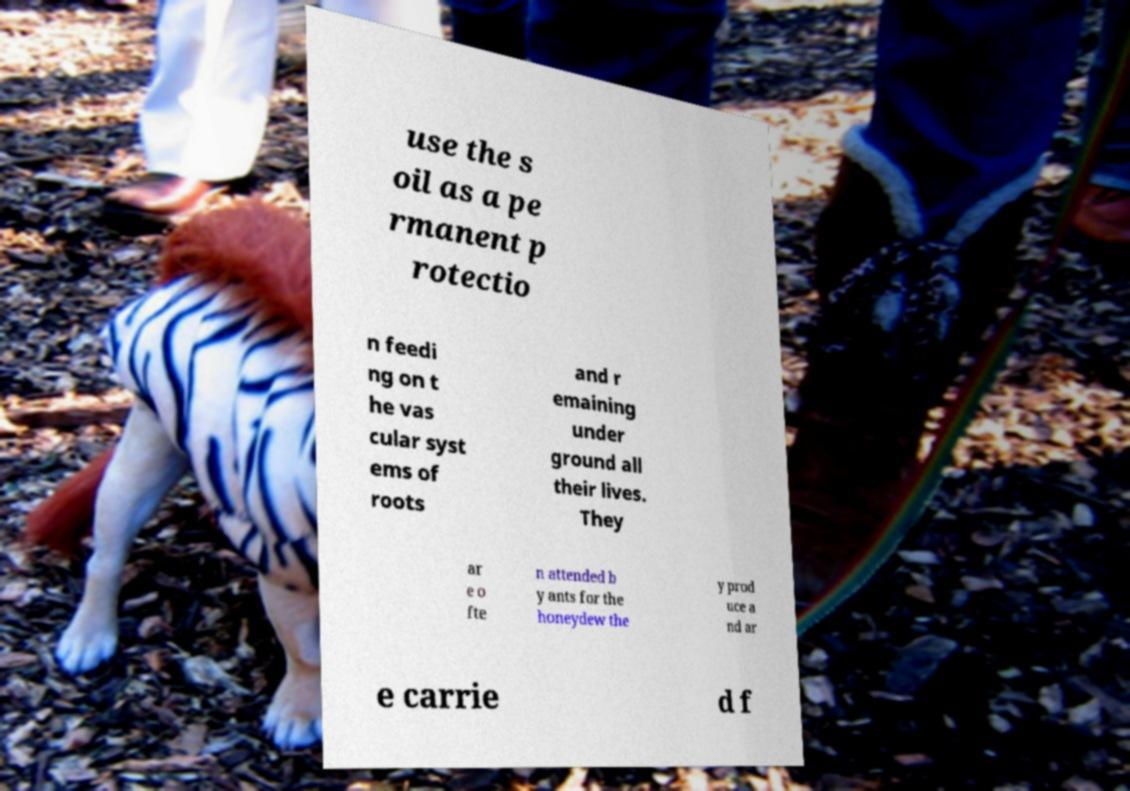What messages or text are displayed in this image? I need them in a readable, typed format. use the s oil as a pe rmanent p rotectio n feedi ng on t he vas cular syst ems of roots and r emaining under ground all their lives. They ar e o fte n attended b y ants for the honeydew the y prod uce a nd ar e carrie d f 